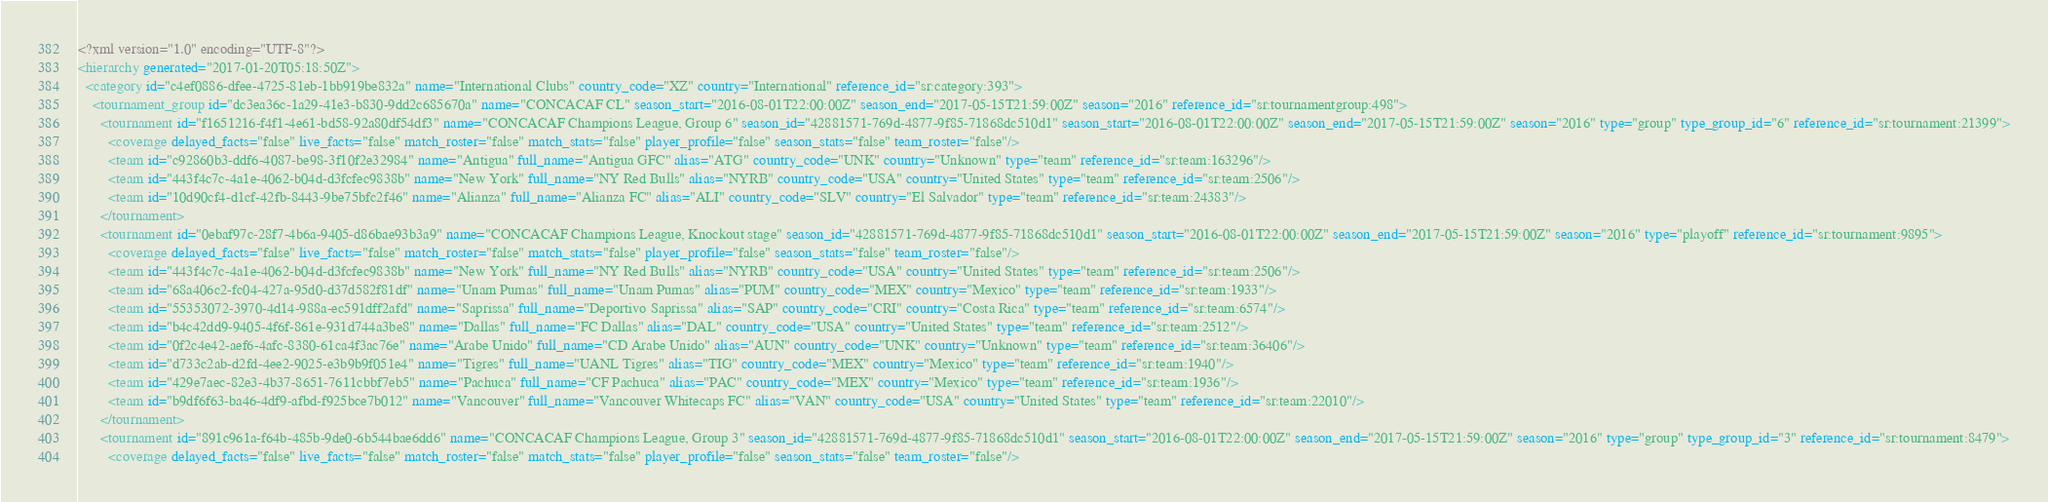Convert code to text. <code><loc_0><loc_0><loc_500><loc_500><_XML_><?xml version="1.0" encoding="UTF-8"?>
<hierarchy generated="2017-01-20T05:18:50Z">
  <category id="c4ef0886-dfee-4725-81eb-1bb919be832a" name="International Clubs" country_code="XZ" country="International" reference_id="sr:category:393">
    <tournament_group id="dc3ea36c-1a29-41e3-b830-9dd2c685670a" name="CONCACAF CL" season_start="2016-08-01T22:00:00Z" season_end="2017-05-15T21:59:00Z" season="2016" reference_id="sr:tournamentgroup:498">
      <tournament id="f1651216-f4f1-4e61-bd58-92a80df54df3" name="CONCACAF Champions League, Group 6" season_id="42881571-769d-4877-9f85-71868dc510d1" season_start="2016-08-01T22:00:00Z" season_end="2017-05-15T21:59:00Z" season="2016" type="group" type_group_id="6" reference_id="sr:tournament:21399">
        <coverage delayed_facts="false" live_facts="false" match_roster="false" match_stats="false" player_profile="false" season_stats="false" team_roster="false"/>
        <team id="c92860b3-ddf6-4087-be98-3f10f2e32984" name="Antigua" full_name="Antigua GFC" alias="ATG" country_code="UNK" country="Unknown" type="team" reference_id="sr:team:163296"/>
        <team id="443f4c7c-4a1e-4062-b04d-d3fcfec9838b" name="New York" full_name="NY Red Bulls" alias="NYRB" country_code="USA" country="United States" type="team" reference_id="sr:team:2506"/>
        <team id="10d90cf4-d1cf-42fb-8443-9be75bfc2f46" name="Alianza" full_name="Alianza FC" alias="ALI" country_code="SLV" country="El Salvador" type="team" reference_id="sr:team:24383"/>
      </tournament>
      <tournament id="0ebaf97c-28f7-4b6a-9405-d86bae93b3a9" name="CONCACAF Champions League, Knockout stage" season_id="42881571-769d-4877-9f85-71868dc510d1" season_start="2016-08-01T22:00:00Z" season_end="2017-05-15T21:59:00Z" season="2016" type="playoff" reference_id="sr:tournament:9895">
        <coverage delayed_facts="false" live_facts="false" match_roster="false" match_stats="false" player_profile="false" season_stats="false" team_roster="false"/>
        <team id="443f4c7c-4a1e-4062-b04d-d3fcfec9838b" name="New York" full_name="NY Red Bulls" alias="NYRB" country_code="USA" country="United States" type="team" reference_id="sr:team:2506"/>
        <team id="68a406c2-fc04-427a-95d0-d37d582f81df" name="Unam Pumas" full_name="Unam Pumas" alias="PUM" country_code="MEX" country="Mexico" type="team" reference_id="sr:team:1933"/>
        <team id="55353072-3970-4d14-988a-ec591dff2afd" name="Saprissa" full_name="Deportivo Saprissa" alias="SAP" country_code="CRI" country="Costa Rica" type="team" reference_id="sr:team:6574"/>
        <team id="b4c42dd9-9405-4f6f-861e-931d744a3be8" name="Dallas" full_name="FC Dallas" alias="DAL" country_code="USA" country="United States" type="team" reference_id="sr:team:2512"/>
        <team id="0f2c4e42-aef6-4afc-8380-61ca4f3ac76e" name="Arabe Unido" full_name="CD Arabe Unido" alias="AUN" country_code="UNK" country="Unknown" type="team" reference_id="sr:team:36406"/>
        <team id="d733c2ab-d2fd-4ee2-9025-e3b9b9f051e4" name="Tigres" full_name="UANL Tigres" alias="TIG" country_code="MEX" country="Mexico" type="team" reference_id="sr:team:1940"/>
        <team id="429e7aec-82e3-4b37-8651-7611cbbf7eb5" name="Pachuca" full_name="CF Pachuca" alias="PAC" country_code="MEX" country="Mexico" type="team" reference_id="sr:team:1936"/>
        <team id="b9df6f63-ba46-4df9-afbd-f925bce7b012" name="Vancouver" full_name="Vancouver Whitecaps FC" alias="VAN" country_code="USA" country="United States" type="team" reference_id="sr:team:22010"/>
      </tournament>
      <tournament id="891c961a-f64b-485b-9de0-6b544bae6dd6" name="CONCACAF Champions League, Group 3" season_id="42881571-769d-4877-9f85-71868dc510d1" season_start="2016-08-01T22:00:00Z" season_end="2017-05-15T21:59:00Z" season="2016" type="group" type_group_id="3" reference_id="sr:tournament:8479">
        <coverage delayed_facts="false" live_facts="false" match_roster="false" match_stats="false" player_profile="false" season_stats="false" team_roster="false"/></code> 